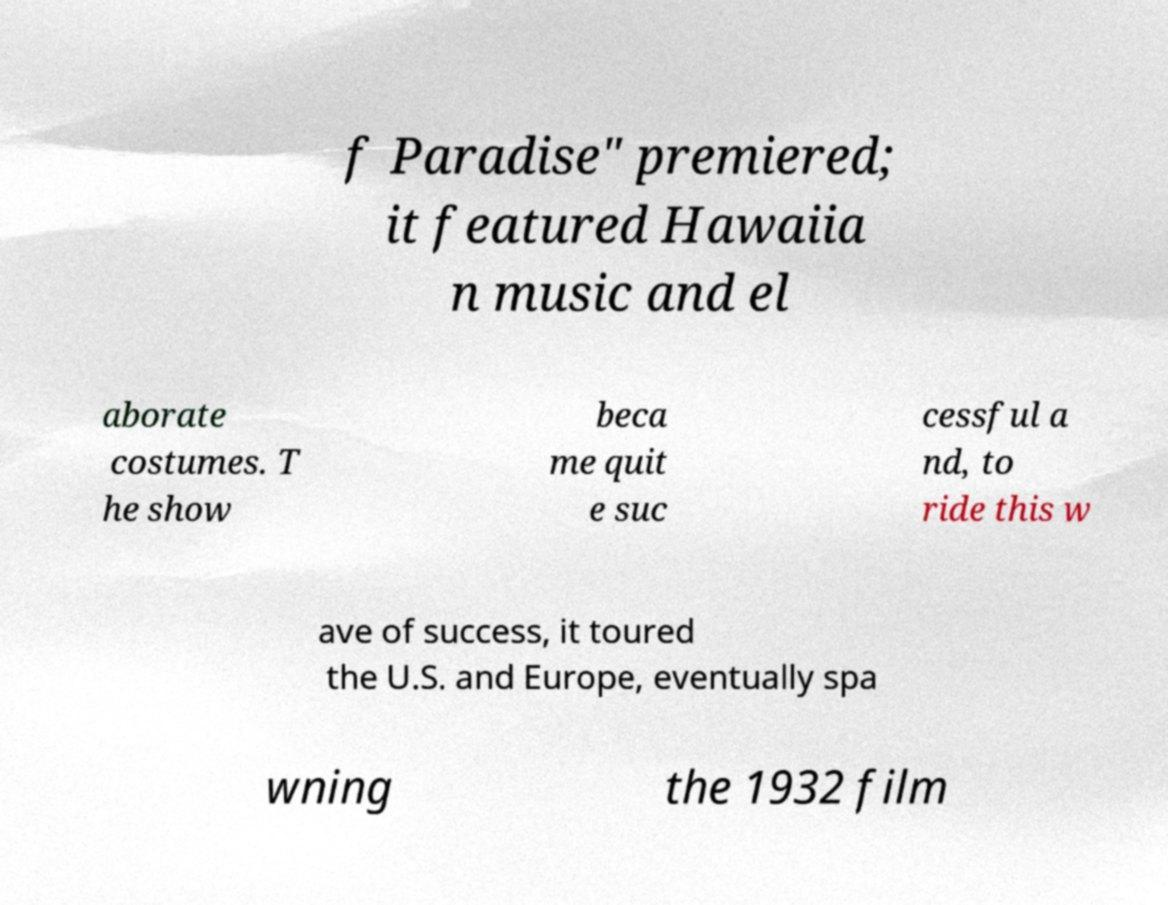Can you read and provide the text displayed in the image?This photo seems to have some interesting text. Can you extract and type it out for me? f Paradise" premiered; it featured Hawaiia n music and el aborate costumes. T he show beca me quit e suc cessful a nd, to ride this w ave of success, it toured the U.S. and Europe, eventually spa wning the 1932 film 